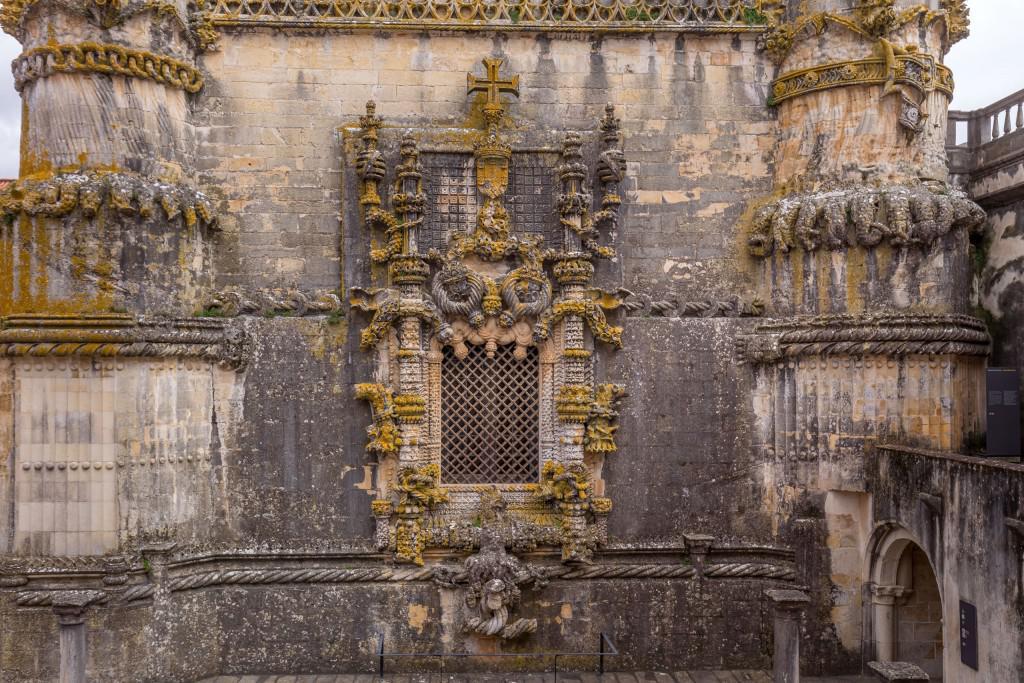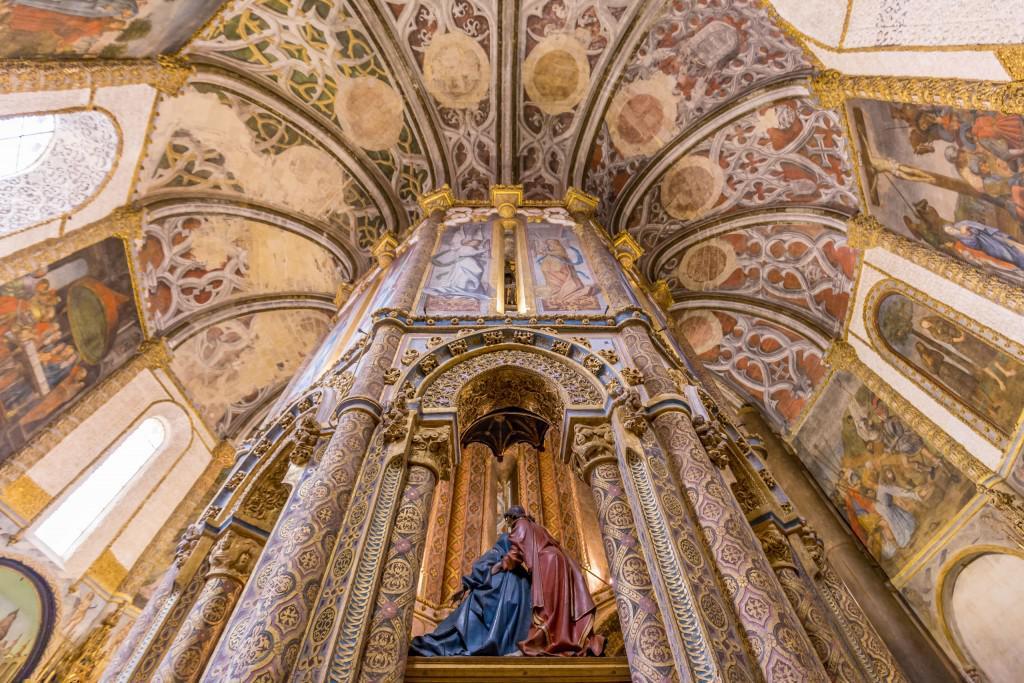The first image is the image on the left, the second image is the image on the right. Given the left and right images, does the statement "In at least one image there are one or more paintings." hold true? Answer yes or no. Yes. The first image is the image on the left, the second image is the image on the right. Considering the images on both sides, is "more then six arches can be seen in the left photo" valid? Answer yes or no. No. 